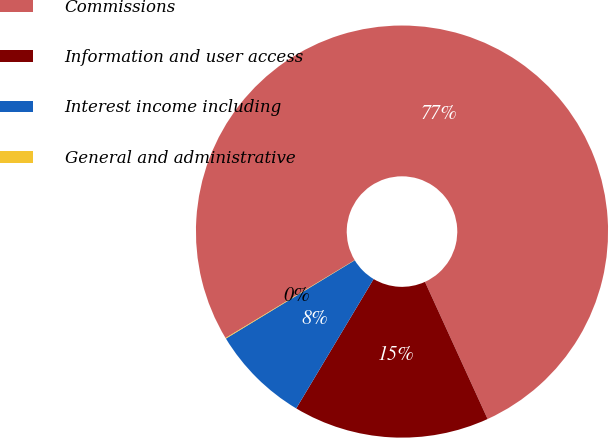<chart> <loc_0><loc_0><loc_500><loc_500><pie_chart><fcel>Commissions<fcel>Information and user access<fcel>Interest income including<fcel>General and administrative<nl><fcel>76.82%<fcel>15.4%<fcel>7.73%<fcel>0.05%<nl></chart> 